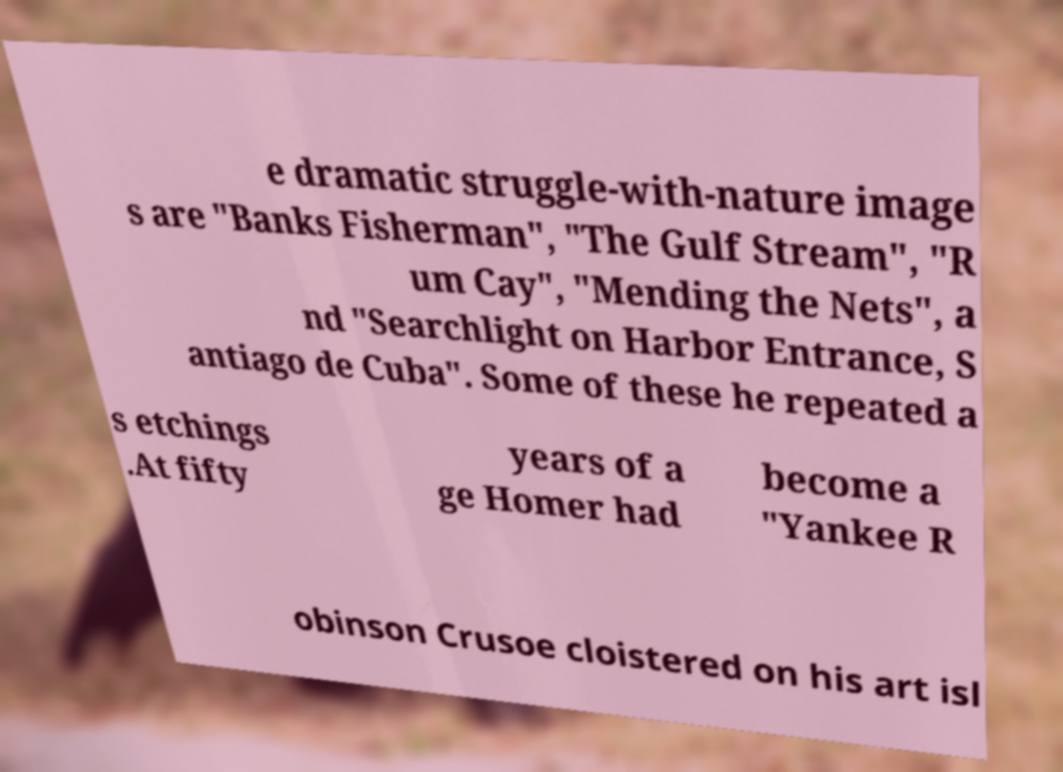Could you assist in decoding the text presented in this image and type it out clearly? e dramatic struggle-with-nature image s are "Banks Fisherman", "The Gulf Stream", "R um Cay", "Mending the Nets", a nd "Searchlight on Harbor Entrance, S antiago de Cuba". Some of these he repeated a s etchings .At fifty years of a ge Homer had become a "Yankee R obinson Crusoe cloistered on his art isl 